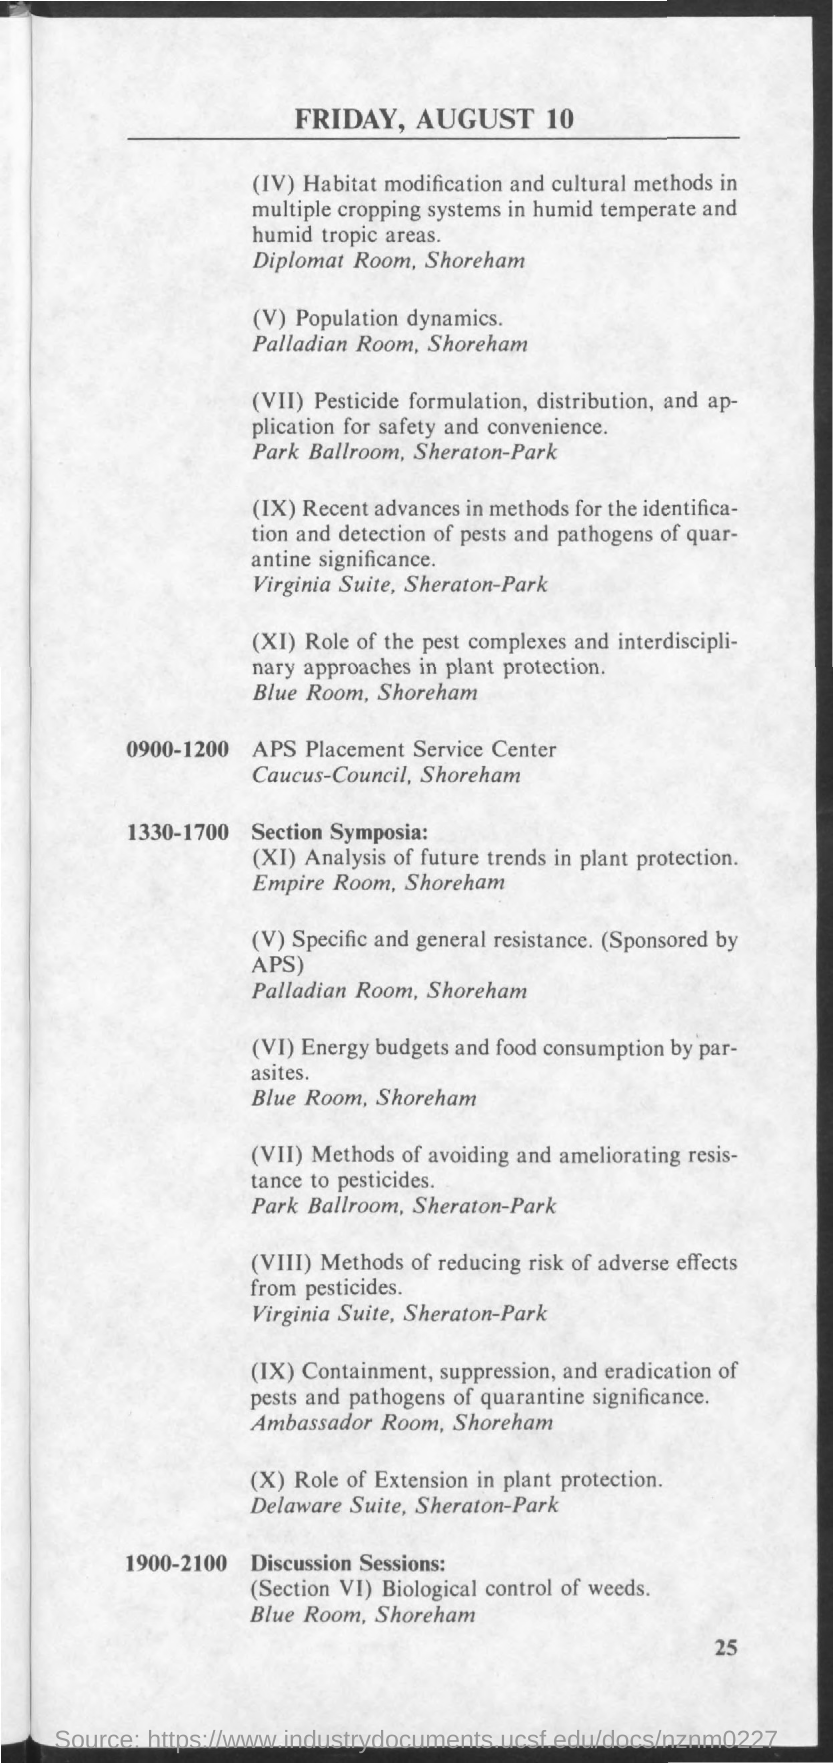Mention a couple of crucial points in this snapshot. The American Physical Society (APS) sponsored the "Specific and general resistance" section. 